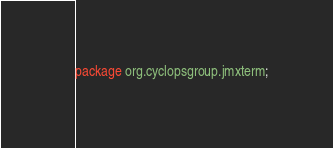Convert code to text. <code><loc_0><loc_0><loc_500><loc_500><_Java_>package org.cyclopsgroup.jmxterm;
</code> 